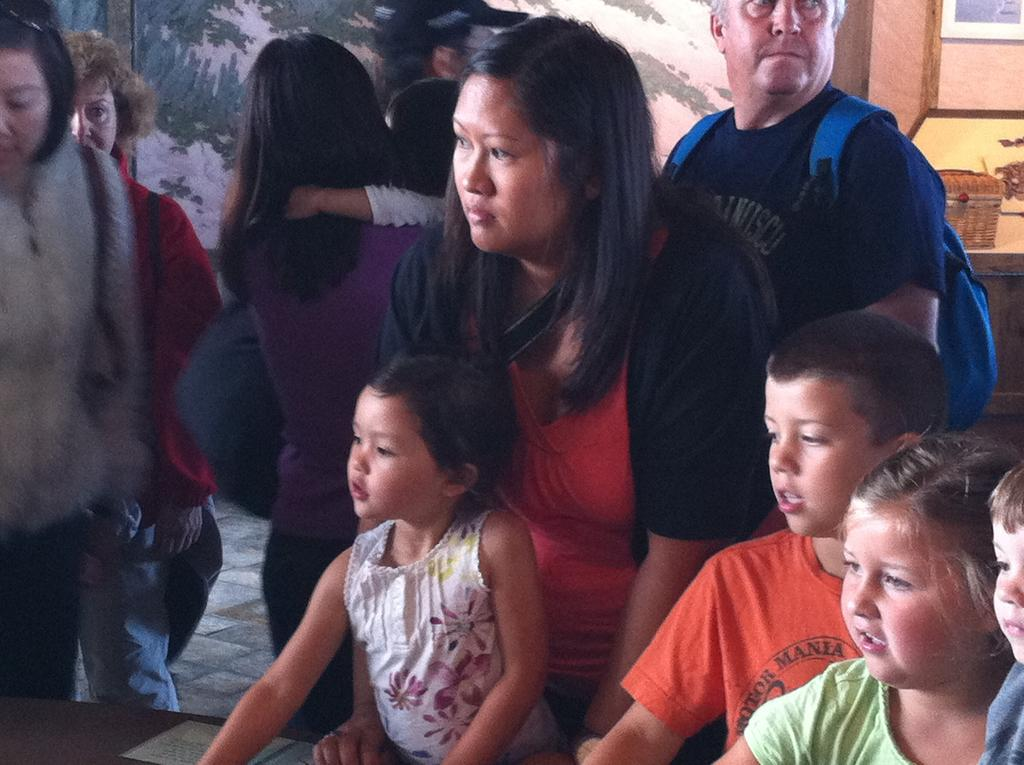Who is present in the image? There are people in the image. Can you describe the age range of the people in the image? Some of the people are children. What can be seen in the background of the image? There is a man in the background carrying a blue bag. What type of harmony is being played by the children in the image? There is no indication of music or harmony in the image; it simply shows people, including children, in a setting. 